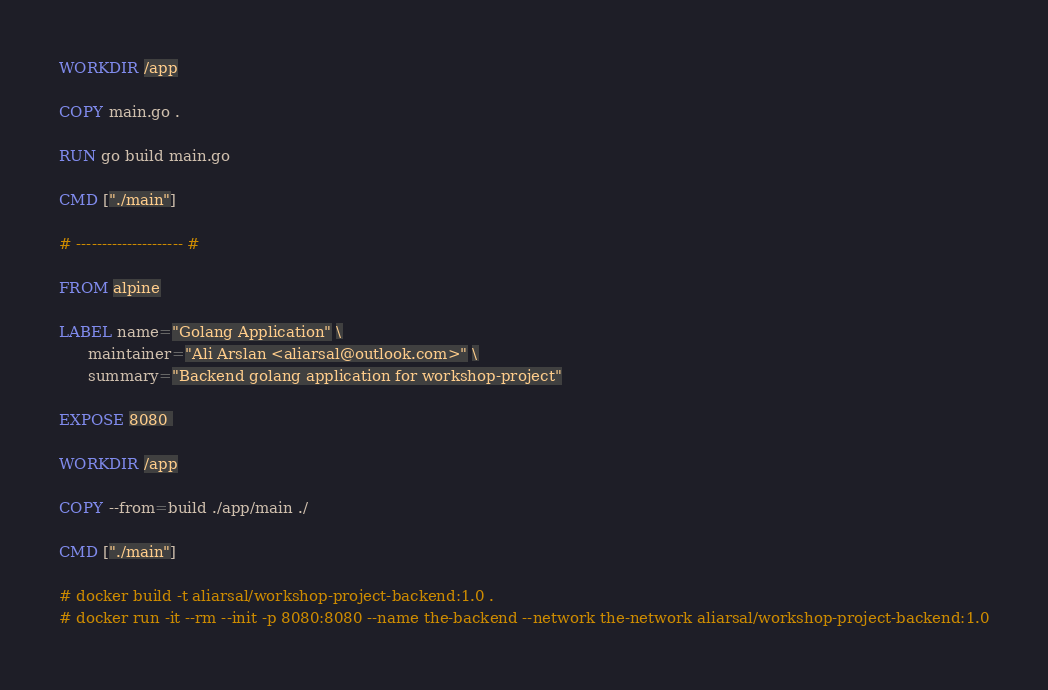Convert code to text. <code><loc_0><loc_0><loc_500><loc_500><_Dockerfile_>
WORKDIR /app

COPY main.go .

RUN go build main.go
 
CMD ["./main"]

# --------------------- #

FROM alpine

LABEL name="Golang Application" \
      maintainer="Ali Arslan <aliarsal@outlook.com>" \
      summary="Backend golang application for workshop-project"

EXPOSE 8080 

WORKDIR /app

COPY --from=build ./app/main ./
 
CMD ["./main"]

# docker build -t aliarsal/workshop-project-backend:1.0 .
# docker run -it --rm --init -p 8080:8080 --name the-backend --network the-network aliarsal/workshop-project-backend:1.0


</code> 